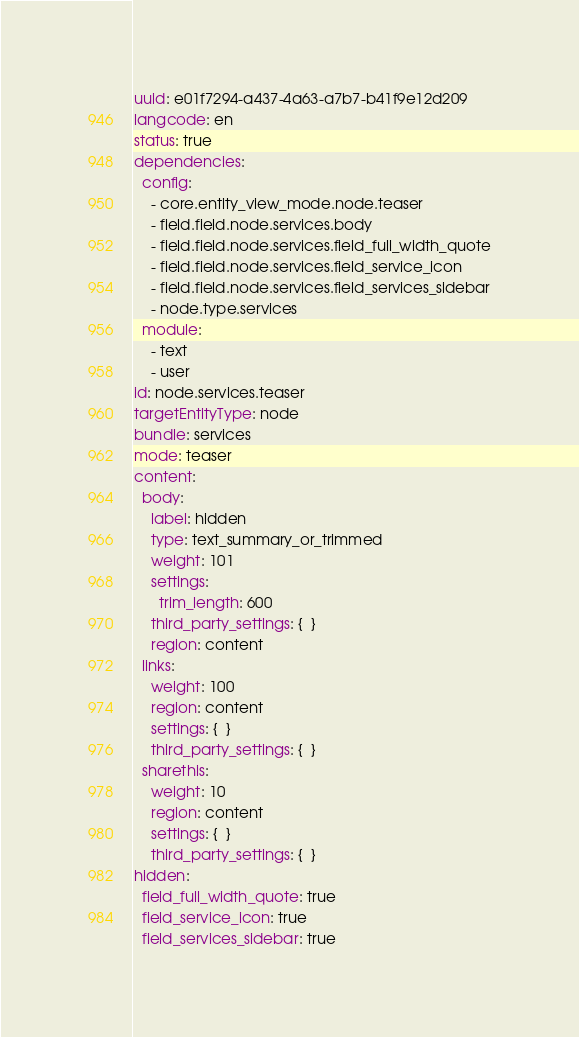<code> <loc_0><loc_0><loc_500><loc_500><_YAML_>uuid: e01f7294-a437-4a63-a7b7-b41f9e12d209
langcode: en
status: true
dependencies:
  config:
    - core.entity_view_mode.node.teaser
    - field.field.node.services.body
    - field.field.node.services.field_full_width_quote
    - field.field.node.services.field_service_icon
    - field.field.node.services.field_services_sidebar
    - node.type.services
  module:
    - text
    - user
id: node.services.teaser
targetEntityType: node
bundle: services
mode: teaser
content:
  body:
    label: hidden
    type: text_summary_or_trimmed
    weight: 101
    settings:
      trim_length: 600
    third_party_settings: {  }
    region: content
  links:
    weight: 100
    region: content
    settings: {  }
    third_party_settings: {  }
  sharethis:
    weight: 10
    region: content
    settings: {  }
    third_party_settings: {  }
hidden:
  field_full_width_quote: true
  field_service_icon: true
  field_services_sidebar: true
</code> 